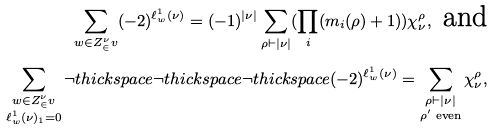<formula> <loc_0><loc_0><loc_500><loc_500>\sum _ { w \in Z ^ { \nu } _ { \in } v } ( - 2 ) ^ { \ell _ { w } ^ { 1 } ( \nu ) } = ( - 1 ) ^ { | \nu | } \sum _ { \rho \vdash | \nu | } ( \prod _ { i } ( m _ { i } ( \rho ) + 1 ) ) \chi _ { \nu } ^ { \rho } , \text { and} \\ \sum _ { \substack { w \in Z ^ { \nu } _ { \in } v \\ \ell _ { w } ^ { 1 } ( \nu ) _ { 1 } = 0 } } \neg t h i c k s p a c e \neg t h i c k s p a c e \neg t h i c k s p a c e ( - 2 ) ^ { \ell _ { w } ^ { 1 } ( \nu ) } = \sum _ { \substack { \rho \vdash | \nu | \\ \rho ^ { \prime } \text { even} } } \chi _ { \nu } ^ { \rho } ,</formula> 